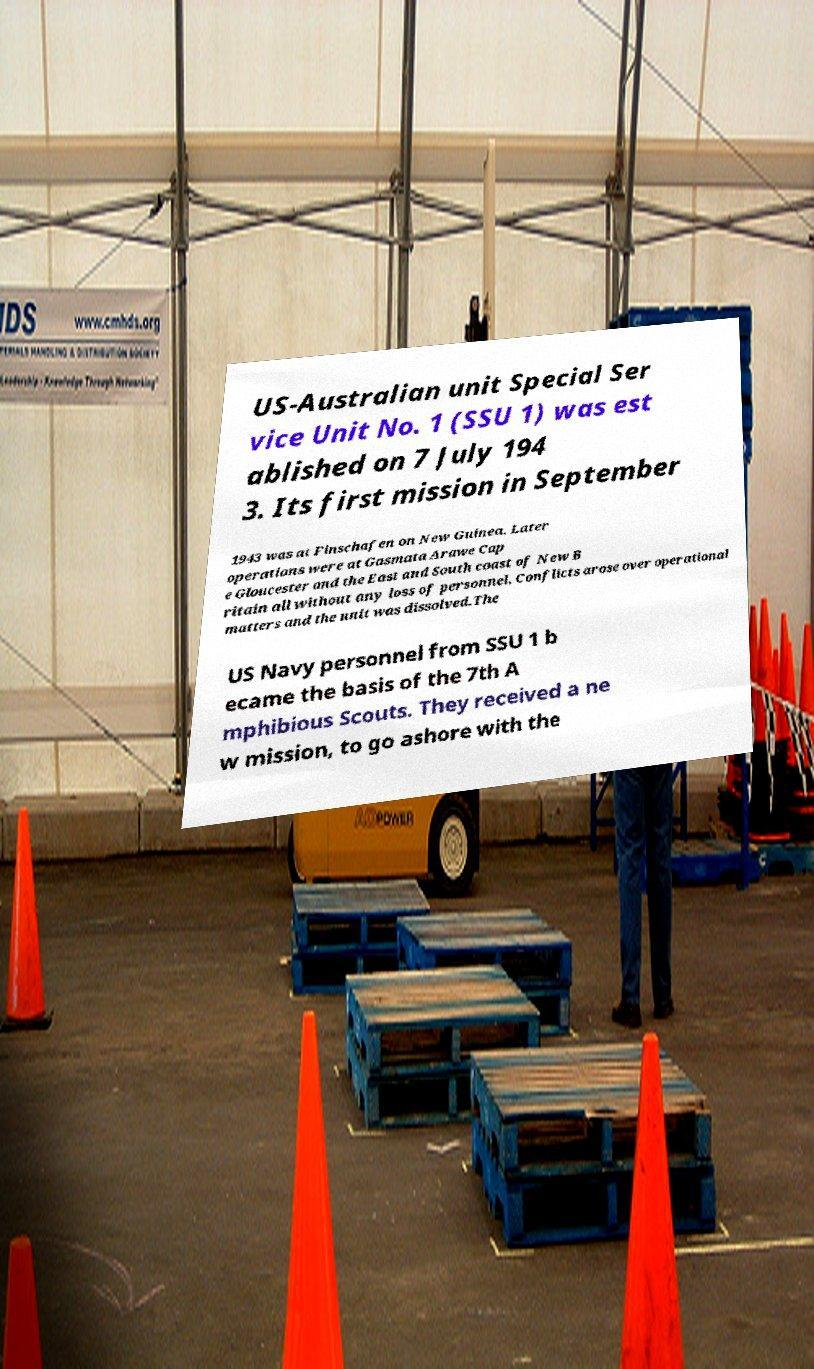Please read and relay the text visible in this image. What does it say? US-Australian unit Special Ser vice Unit No. 1 (SSU 1) was est ablished on 7 July 194 3. Its first mission in September 1943 was at Finschafen on New Guinea. Later operations were at Gasmata Arawe Cap e Gloucester and the East and South coast of New B ritain all without any loss of personnel. Conflicts arose over operational matters and the unit was dissolved.The US Navy personnel from SSU 1 b ecame the basis of the 7th A mphibious Scouts. They received a ne w mission, to go ashore with the 